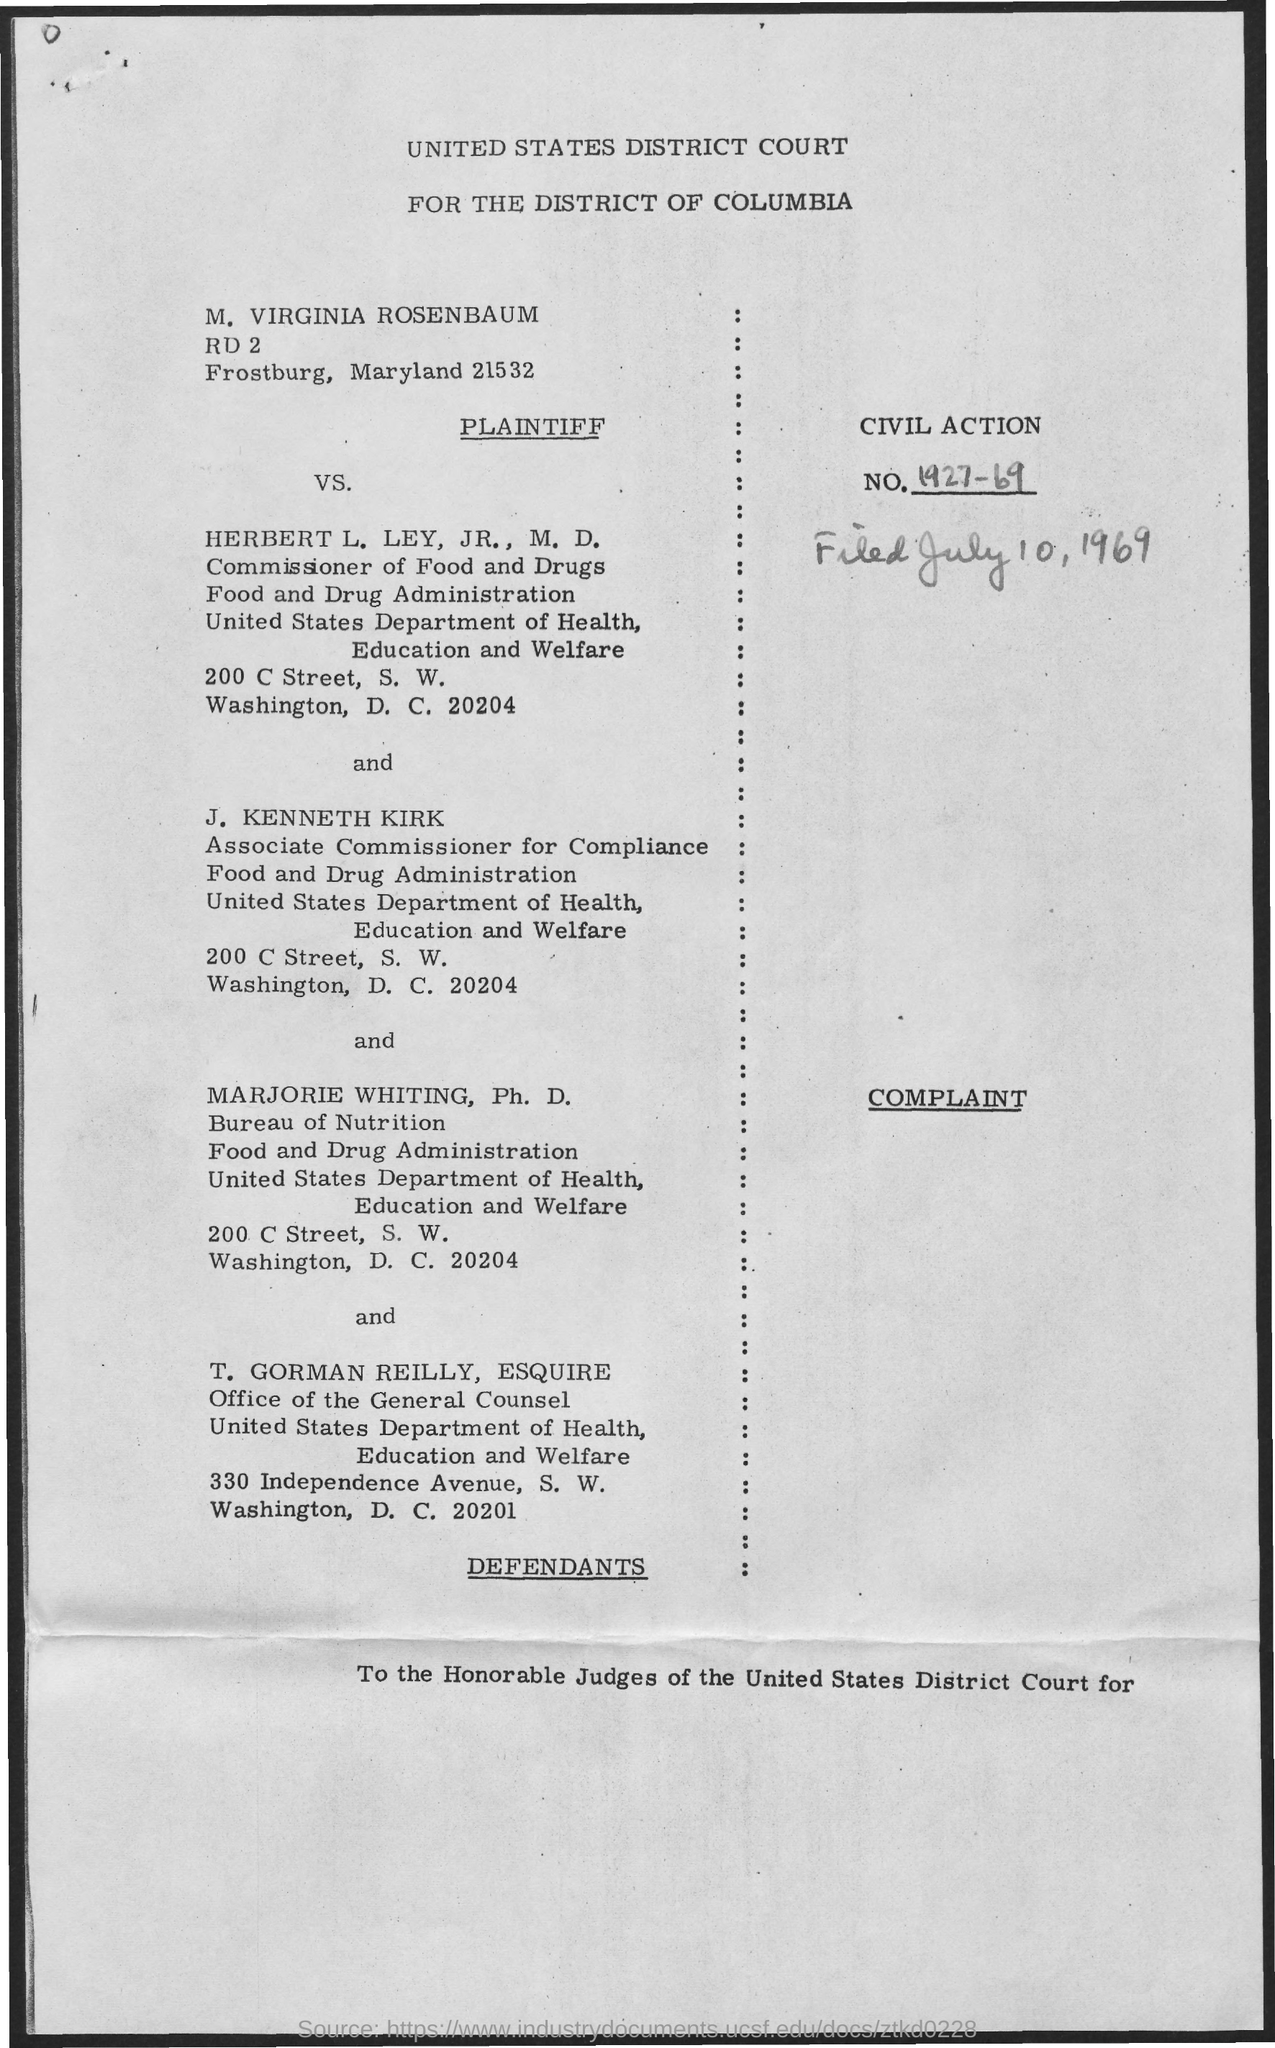Indicate a few pertinent items in this graphic. What is the Civil Action No. 1927-69?" is a question asking for information about a specific legal case or proceeding identified by its Civil Action No. The date mentioned is July 10, 1969. T. Gorman Reilly belongs to the United States department of health, education, and welfare. 